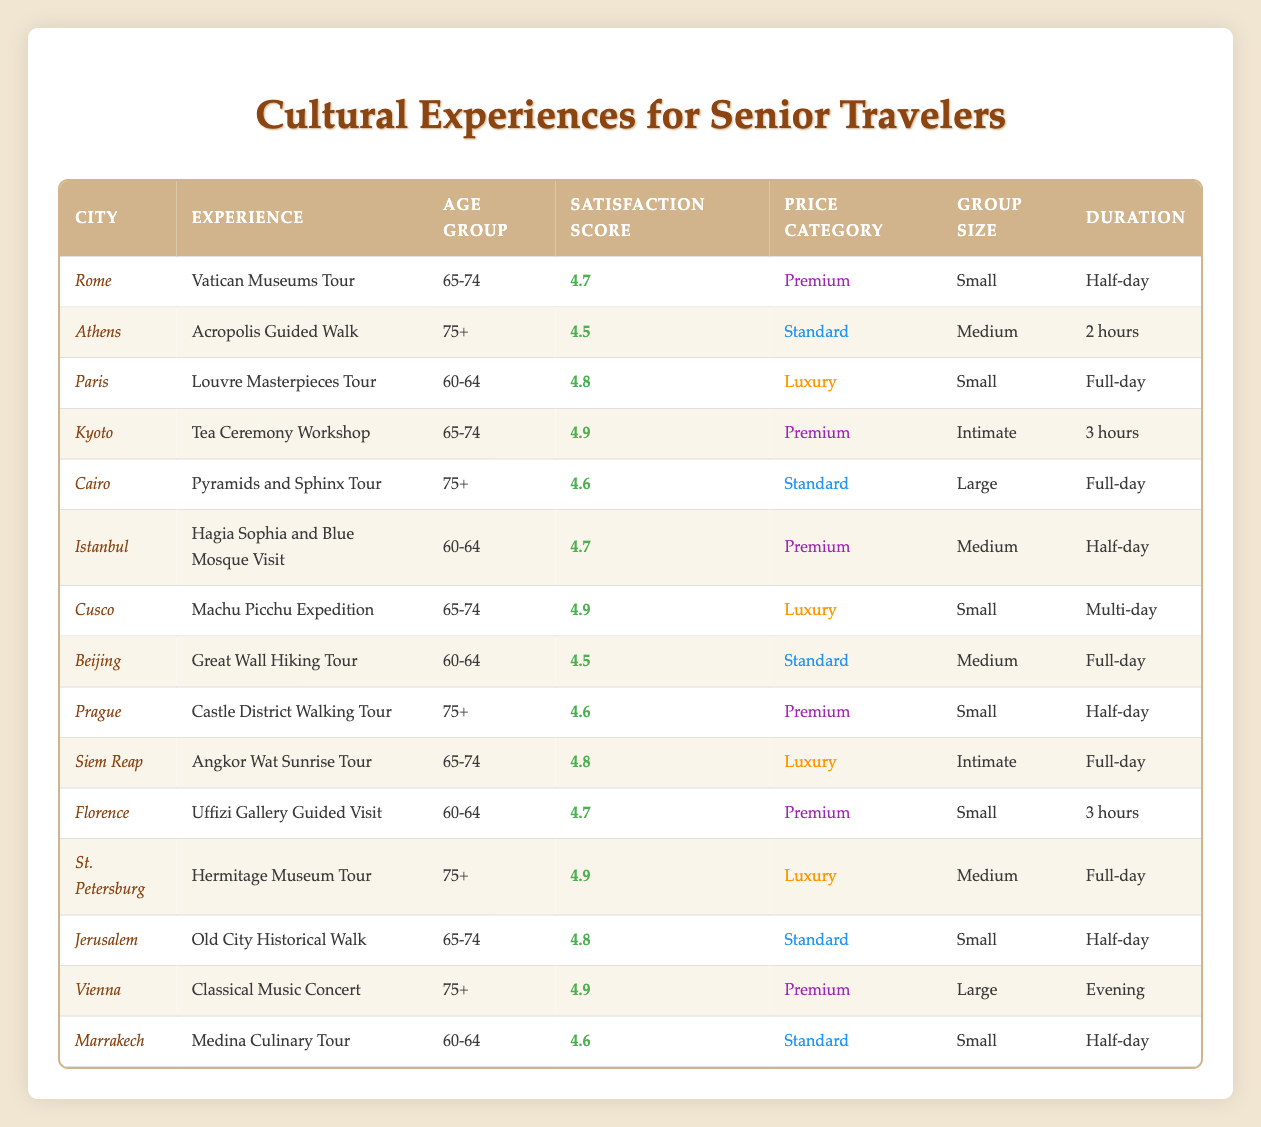What is the satisfaction score for the "Hagia Sophia and Blue Mosque Visit" in Istanbul? According to the table, the "Hagia Sophia and Blue Mosque Visit" has a satisfaction score of 4.7.
Answer: 4.7 Which cultural experience in Florence has the highest satisfaction score? In Florence, the "Uffizi Gallery Guided Visit" has a satisfaction score of 4.7, which is the only experience listed for that city.
Answer: 4.7 Is there any experience rated 5.0 for satisfaction score? Looking at the table entries, none of the experiences have a rating of 5.0; thus, the answer is no.
Answer: No What is the average satisfaction score for experiences available to the age group of 65-74? The satisfaction scores for the age group 65-74 from the table are 4.7 (Rome), 4.9 (Kyoto), 4.9 (Cusco), 4.8 (Jerusalem), and 4.8 (Siem Reap). Summing these scores gives 4.7 + 4.9 + 4.9 + 4.8 + 4.8 = 24.1. Dividing by 5 gives an average of 24.1/5 = 4.82.
Answer: 4.82 In which city is the "Classical Music Concert" located, and what is its price category? The "Classical Music Concert" is located in Vienna, and its price category is "Premium."
Answer: Vienna, Premium How many experiences specifically target the age group of 75+? From the table, there are three experiences targeting the age group of 75+, which are: "Acropolis Guided Walk" (Athens), "Pyramids and Sphinx Tour" (Cairo), and "Castle District Walking Tour" (Prague).
Answer: 3 Is the "Machu Picchu Expedition" a luxury experience? Yes, according to the table, the "Machu Picchu Expedition" is categorized as a luxury experience.
Answer: Yes Which city has the highest satisfaction score among experiences for the age group of 60-64? The satisfaction scores for experiences targeting the age group of 60-64 are: "Louvre Masterpieces Tour" (Paris) with 4.8, "Great Wall Hiking Tour" (Beijing) with 4.5, "Hagia Sophia and Blue Mosque Visit" (Istanbul) with 4.7, and "Uffizi Gallery Guided Visit" (Florence) with 4.7. The highest score is 4.8 from the Louvre Masterpieces Tour in Paris.
Answer: Paris, 4.8 What is the duration of the "Angkor Wat Sunrise Tour"? The duration of the "Angkor Wat Sunrise Tour" is mentioned in the table as "Full-day."
Answer: Full-day 